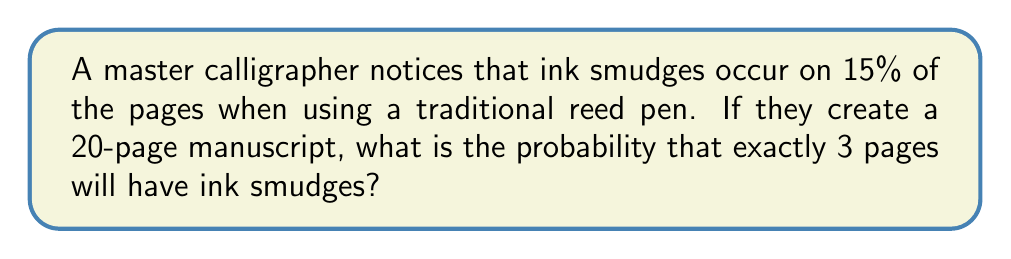Teach me how to tackle this problem. To solve this problem, we need to use the binomial probability distribution, as we have a fixed number of independent trials (pages) with two possible outcomes (smudge or no smudge) and a constant probability of success (smudge occurring).

Let's define our variables:
$n = 20$ (number of pages)
$k = 3$ (number of pages with smudges we're interested in)
$p = 0.15$ (probability of a smudge on a single page)
$q = 1 - p = 0.85$ (probability of no smudge on a single page)

The binomial probability formula is:

$$P(X = k) = \binom{n}{k} p^k q^{n-k}$$

Where $\binom{n}{k}$ is the binomial coefficient, calculated as:

$$\binom{n}{k} = \frac{n!}{k!(n-k)!}$$

Step 1: Calculate the binomial coefficient
$$\binom{20}{3} = \frac{20!}{3!(20-3)!} = \frac{20!}{3!17!} = 1140$$

Step 2: Apply the binomial probability formula
$$P(X = 3) = 1140 \times (0.15)^3 \times (0.85)^{17}$$

Step 3: Calculate the final probability
$$P(X = 3) = 1140 \times 0.003375 \times 0.0437 \approx 0.1681$$

Therefore, the probability of exactly 3 pages having ink smudges in a 20-page manuscript is approximately 0.1681 or 16.81%.
Answer: 0.1681 